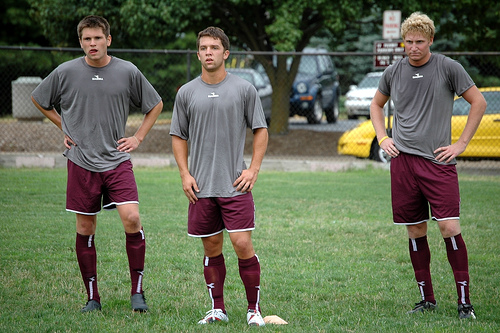<image>
Is the player next to the player? Yes. The player is positioned adjacent to the player, located nearby in the same general area. 